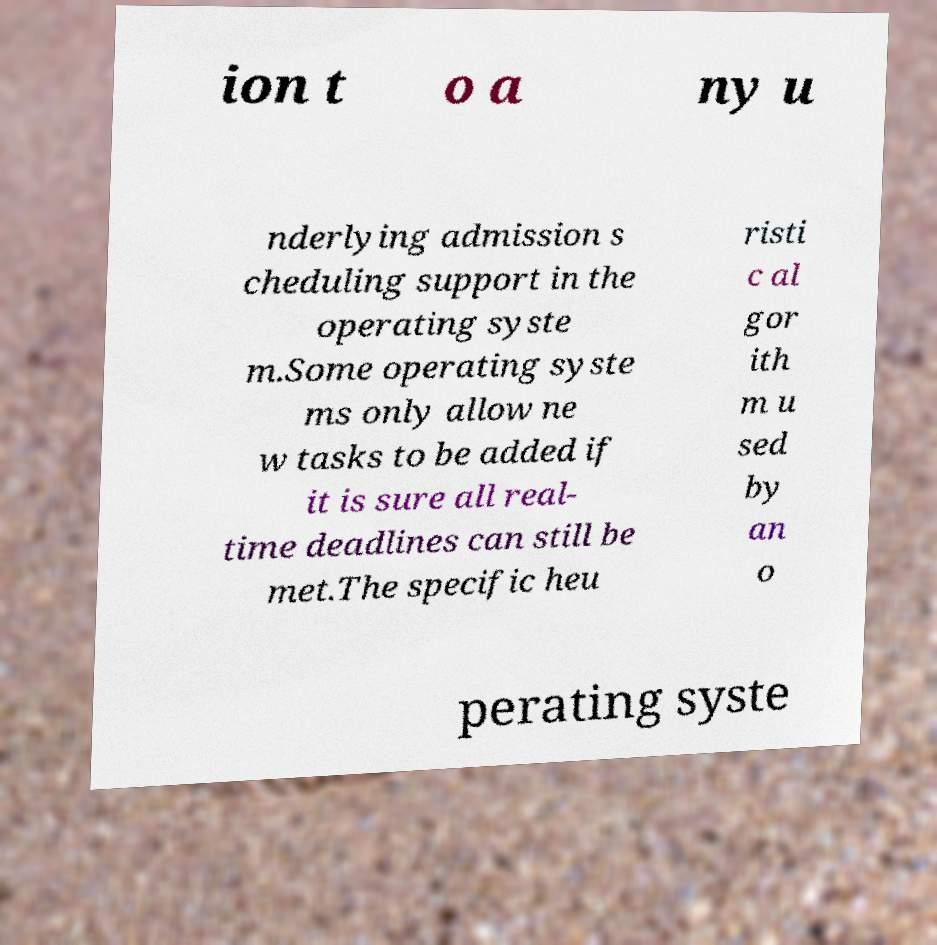Can you read and provide the text displayed in the image?This photo seems to have some interesting text. Can you extract and type it out for me? ion t o a ny u nderlying admission s cheduling support in the operating syste m.Some operating syste ms only allow ne w tasks to be added if it is sure all real- time deadlines can still be met.The specific heu risti c al gor ith m u sed by an o perating syste 